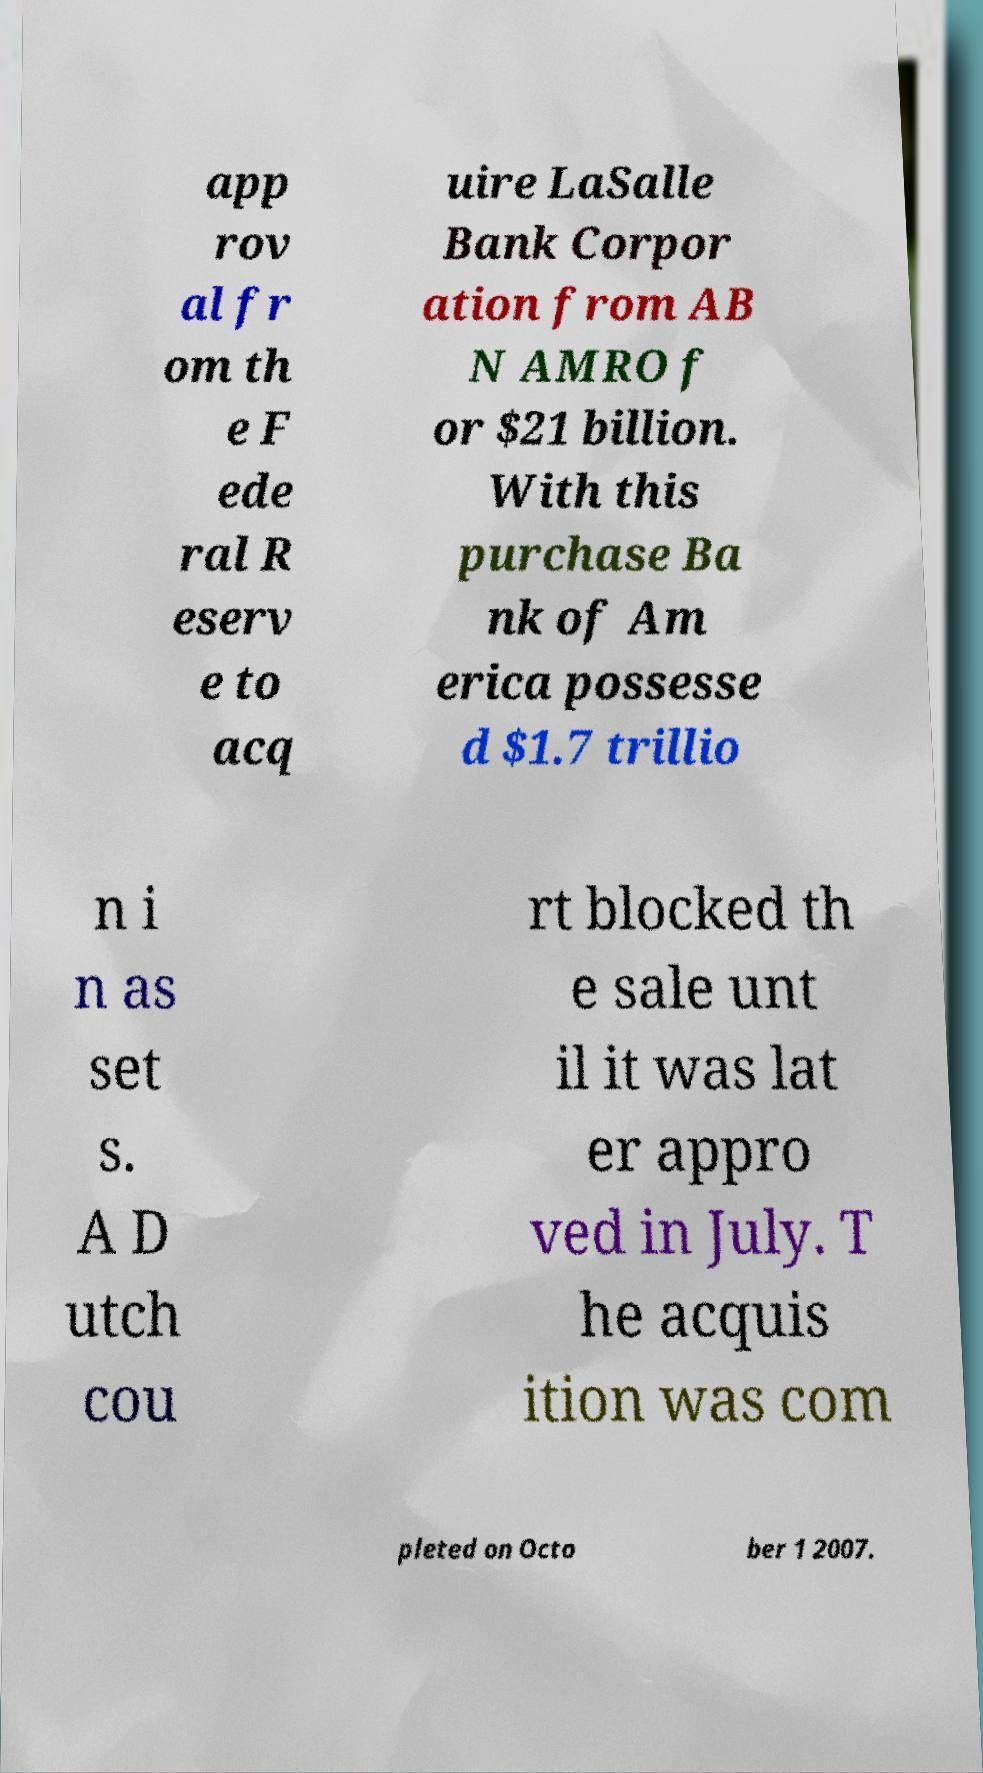For documentation purposes, I need the text within this image transcribed. Could you provide that? app rov al fr om th e F ede ral R eserv e to acq uire LaSalle Bank Corpor ation from AB N AMRO f or $21 billion. With this purchase Ba nk of Am erica possesse d $1.7 trillio n i n as set s. A D utch cou rt blocked th e sale unt il it was lat er appro ved in July. T he acquis ition was com pleted on Octo ber 1 2007. 